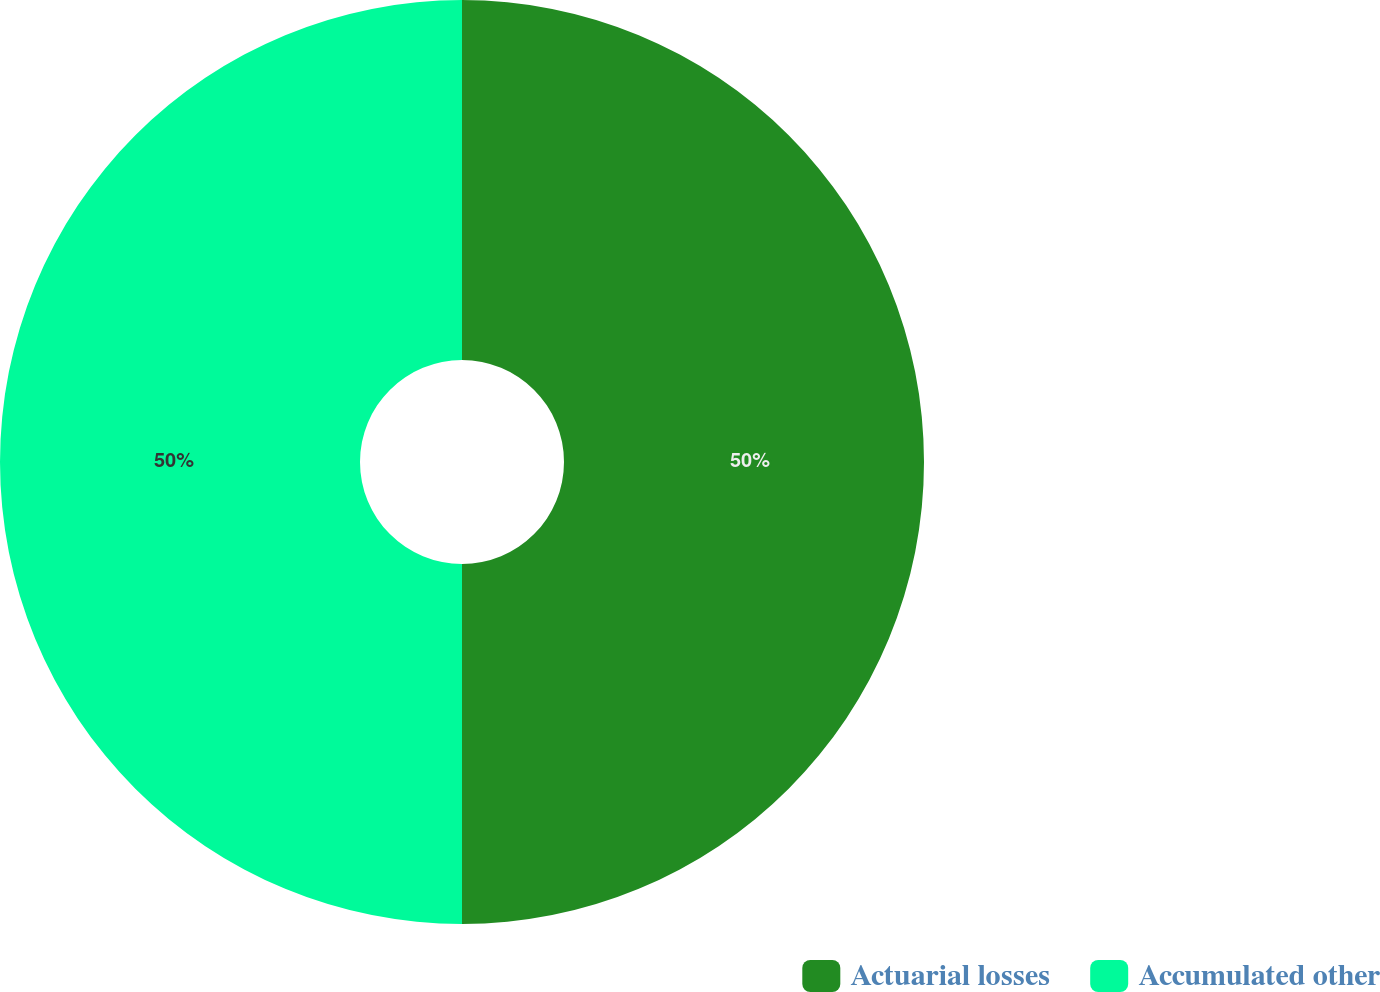Convert chart to OTSL. <chart><loc_0><loc_0><loc_500><loc_500><pie_chart><fcel>Actuarial losses<fcel>Accumulated other<nl><fcel>50.0%<fcel>50.0%<nl></chart> 